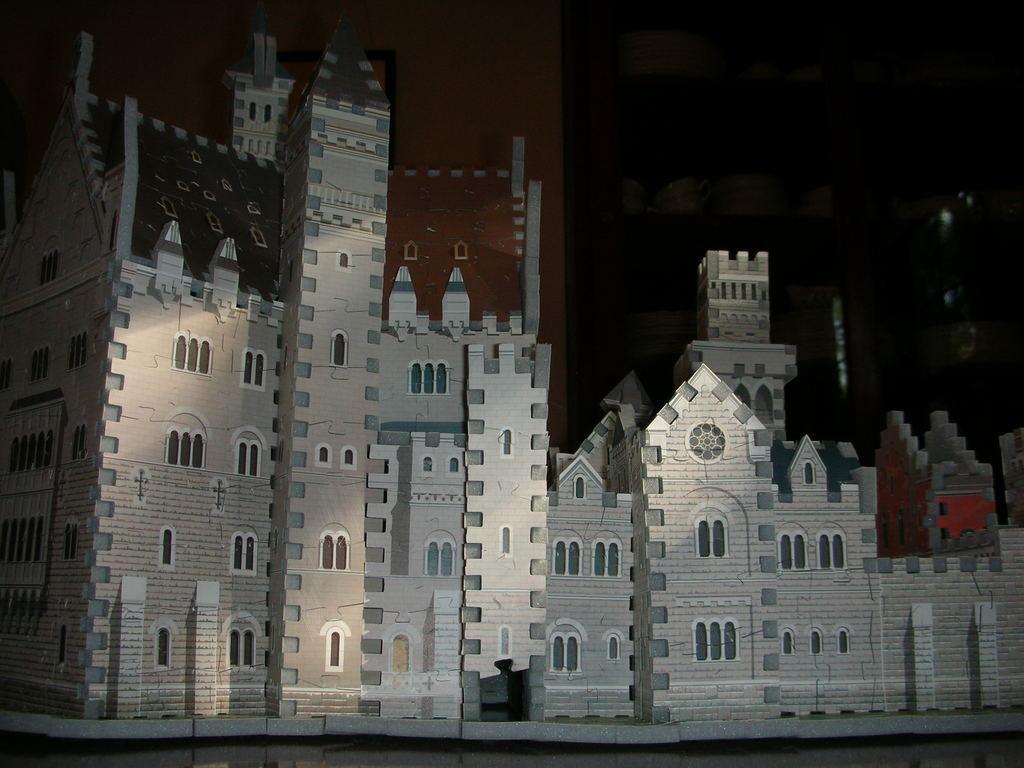Could you give a brief overview of what you see in this image? In this image we can see there is a depiction of a building. The background is dark. 